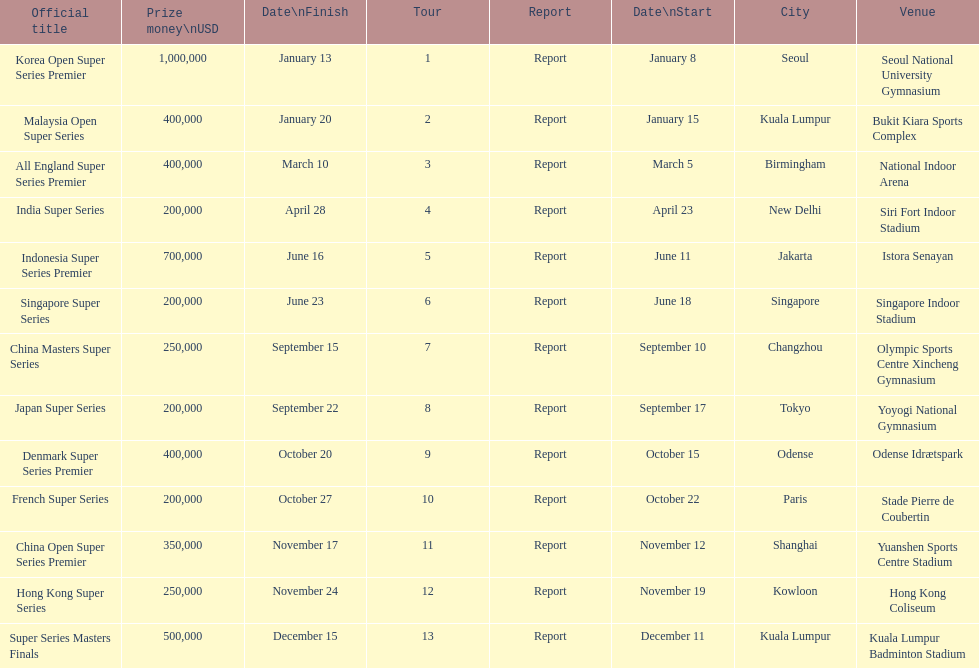How many events of the 2013 bwf super series pay over $200,000? 9. 